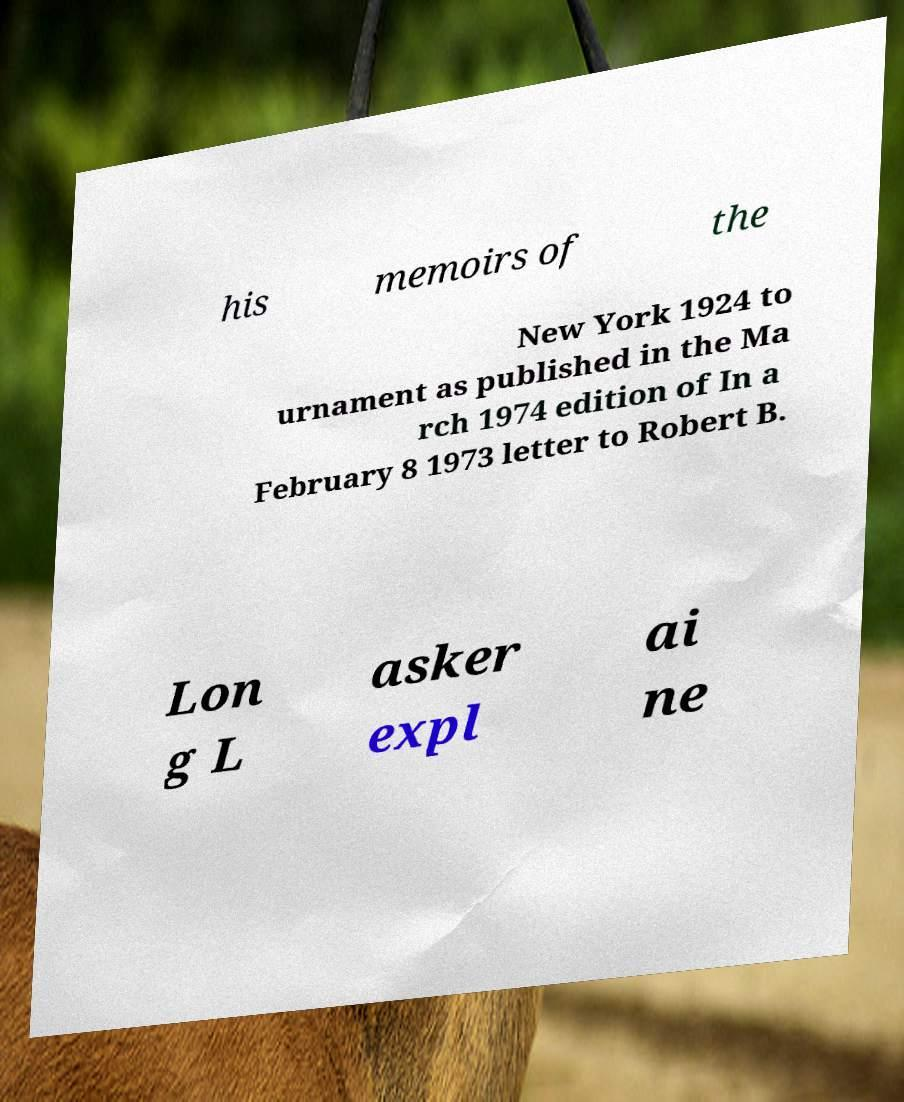Can you accurately transcribe the text from the provided image for me? his memoirs of the New York 1924 to urnament as published in the Ma rch 1974 edition of In a February 8 1973 letter to Robert B. Lon g L asker expl ai ne 